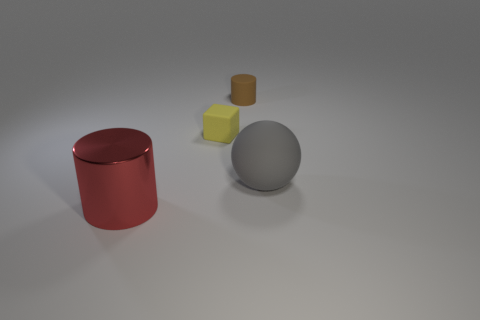Subtract all green balls. Subtract all cyan blocks. How many balls are left? 1 Subtract all brown spheres. How many cyan cubes are left? 0 Add 1 large objects. How many yellows exist? 0 Subtract all yellow objects. Subtract all gray things. How many objects are left? 2 Add 1 cubes. How many cubes are left? 2 Add 3 gray things. How many gray things exist? 4 Add 4 small matte things. How many objects exist? 8 Subtract all brown cylinders. How many cylinders are left? 1 Subtract 0 yellow cylinders. How many objects are left? 4 Subtract all balls. How many objects are left? 3 